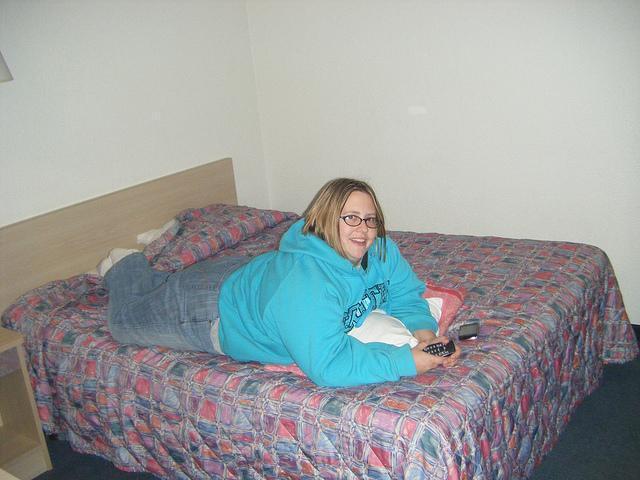How many chairs are there?
Give a very brief answer. 0. 